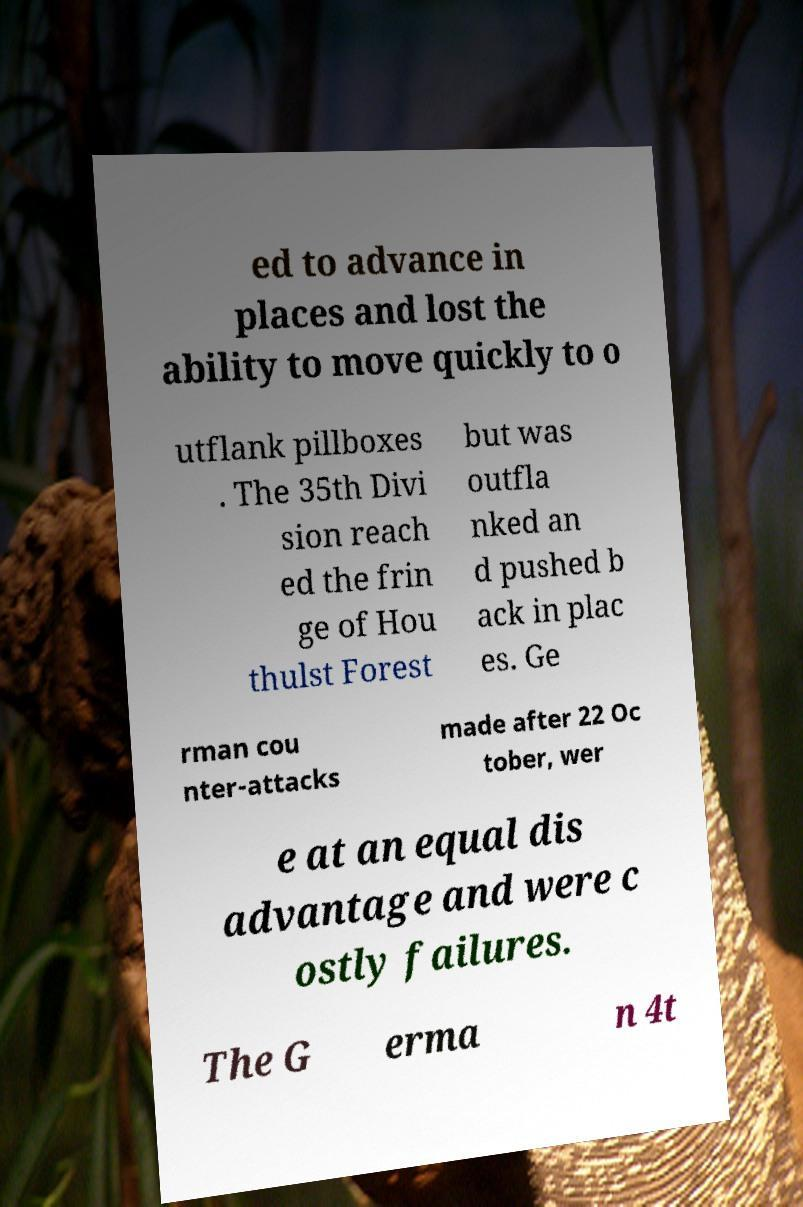For documentation purposes, I need the text within this image transcribed. Could you provide that? ed to advance in places and lost the ability to move quickly to o utflank pillboxes . The 35th Divi sion reach ed the frin ge of Hou thulst Forest but was outfla nked an d pushed b ack in plac es. Ge rman cou nter-attacks made after 22 Oc tober, wer e at an equal dis advantage and were c ostly failures. The G erma n 4t 